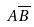Convert formula to latex. <formula><loc_0><loc_0><loc_500><loc_500>A \overline { B }</formula> 